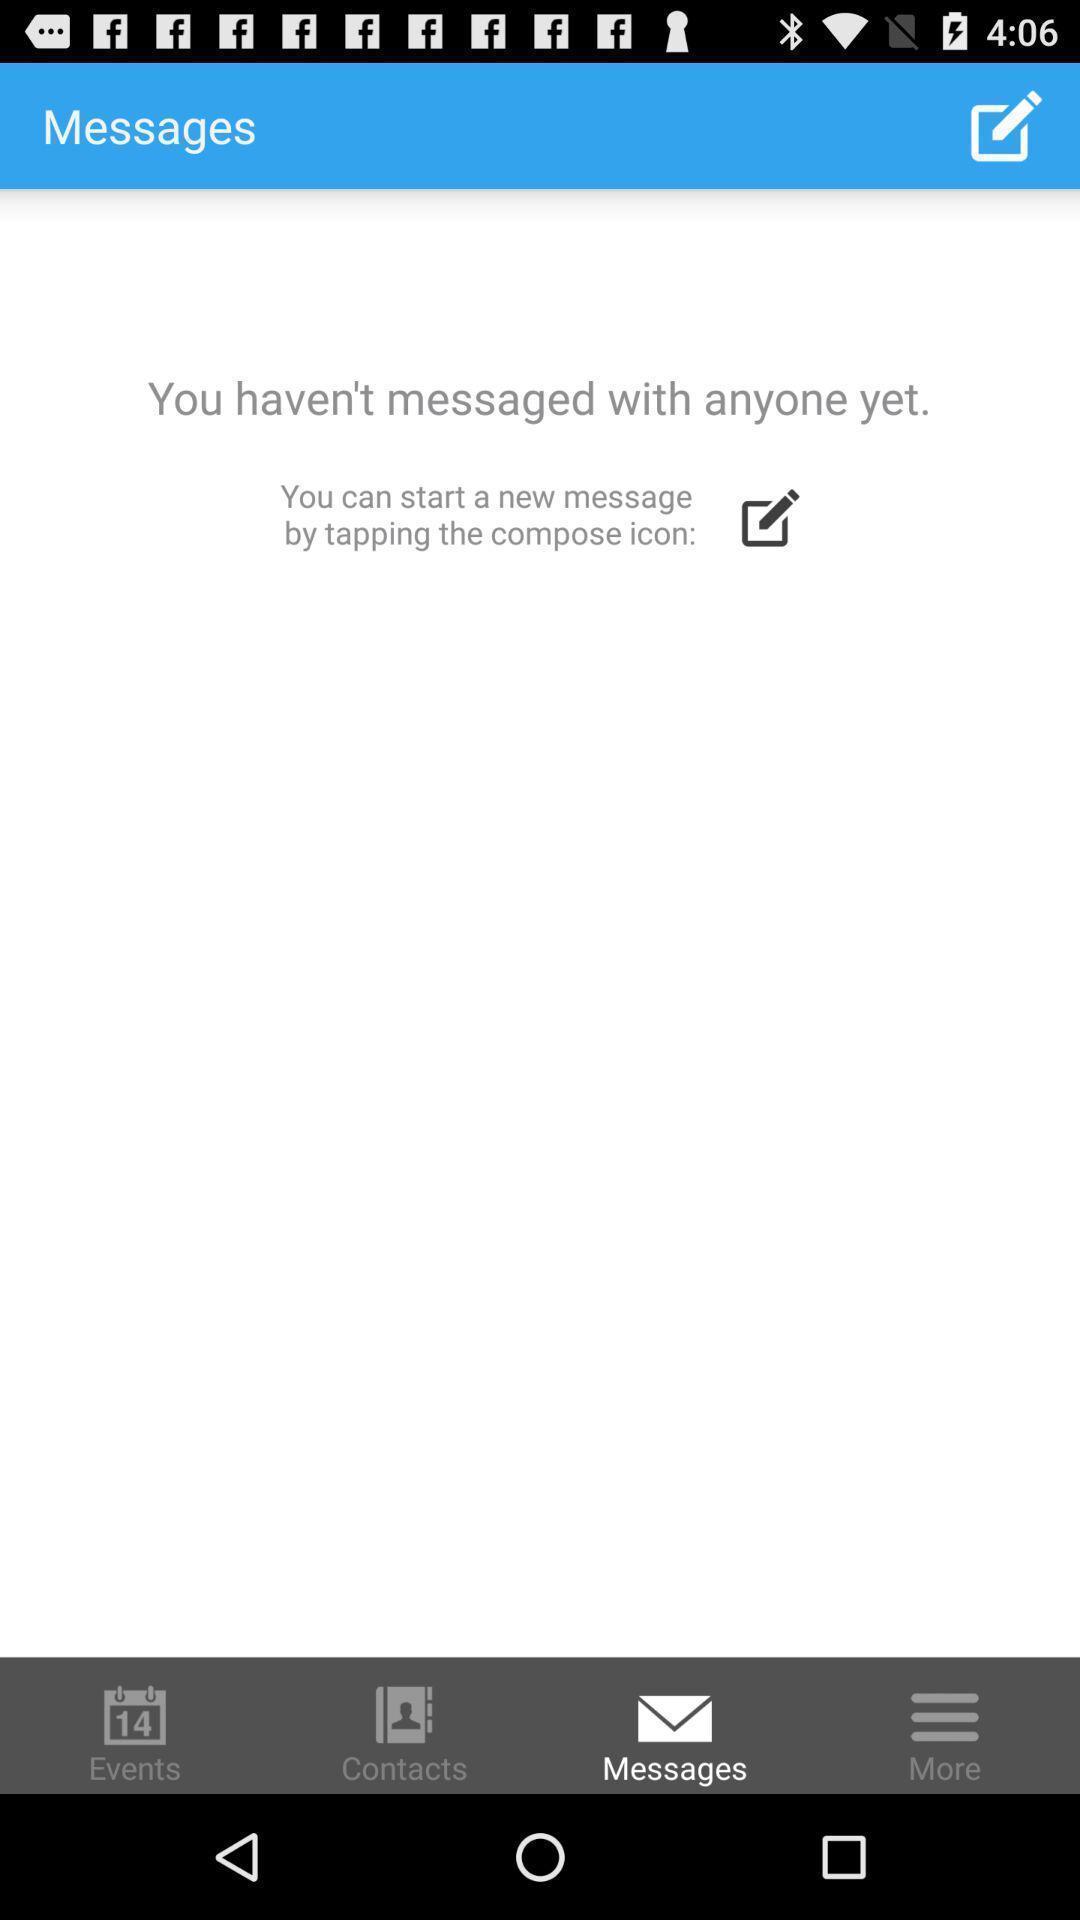Tell me what you see in this picture. Screen displaying different kinds of icons. 